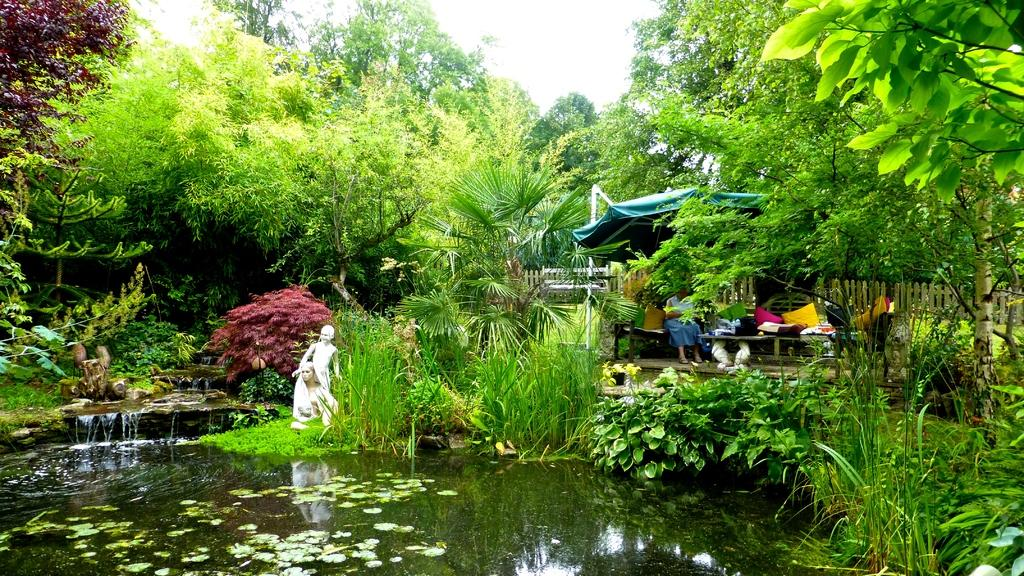What is the primary element visible in the image? There is water in the image. What other objects or features can be seen in the image? There are sculptures, plants, trees, a fence, persons, pillows, and the sky visible in the image. Can you describe the setting or environment in the image? The image features a water setting with various plants, trees, and sculptures, as well as a fence and persons. What might be used for seating or comfort in the image? Pillows are present in the image for seating or comfort. What is visible in the background of the image? The sky is visible in the background of the image. What type of engine is powering the boat in the image? There is no boat present in the image, so it is not possible to determine what type of engine might be powering it. 